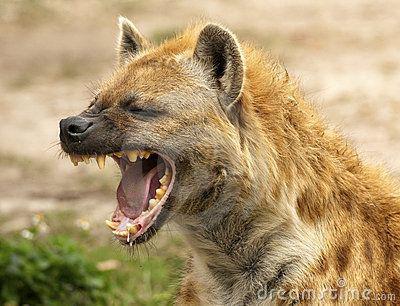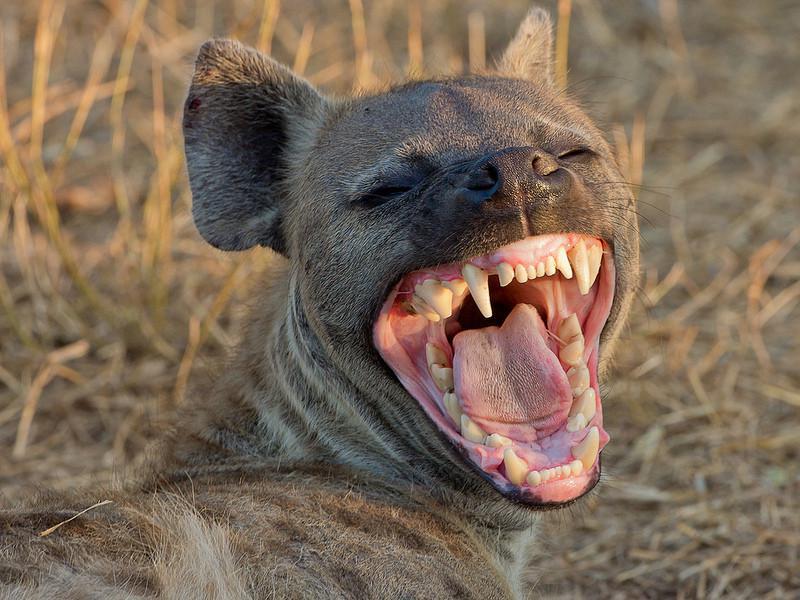The first image is the image on the left, the second image is the image on the right. Considering the images on both sides, is "Exactly one hyena is showing his teeth and exactly one isn't." valid? Answer yes or no. No. The first image is the image on the left, the second image is the image on the right. For the images displayed, is the sentence "There is at least one pup present." factually correct? Answer yes or no. No. 